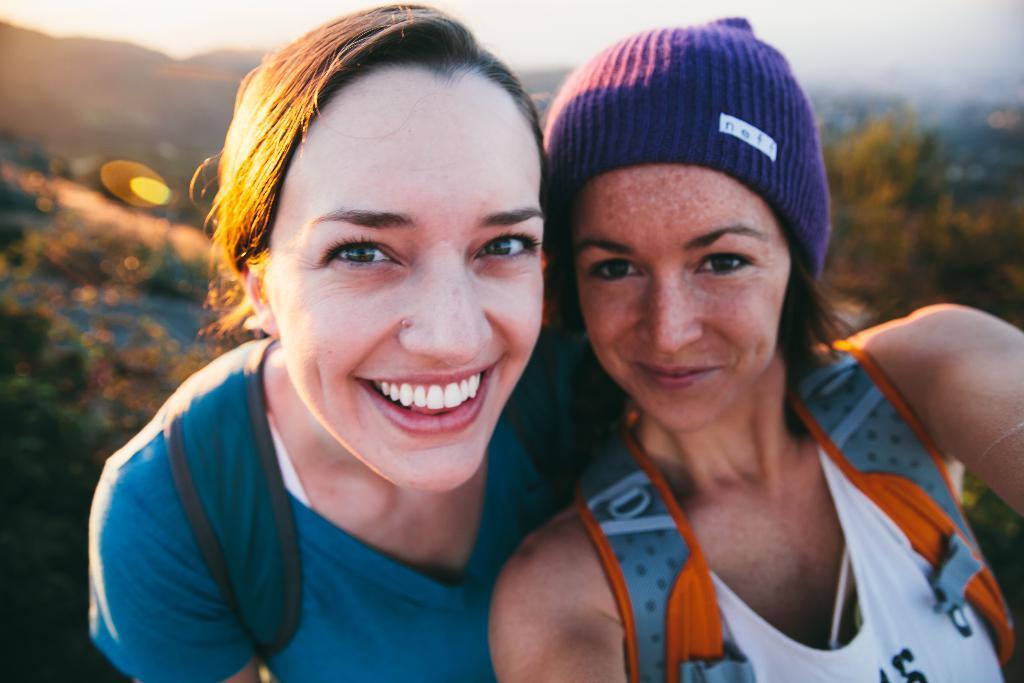How would you summarize this image in a sentence or two? In the image to women are taking selfie,both of them carrying bags on their back,the background of the woman is blur. 